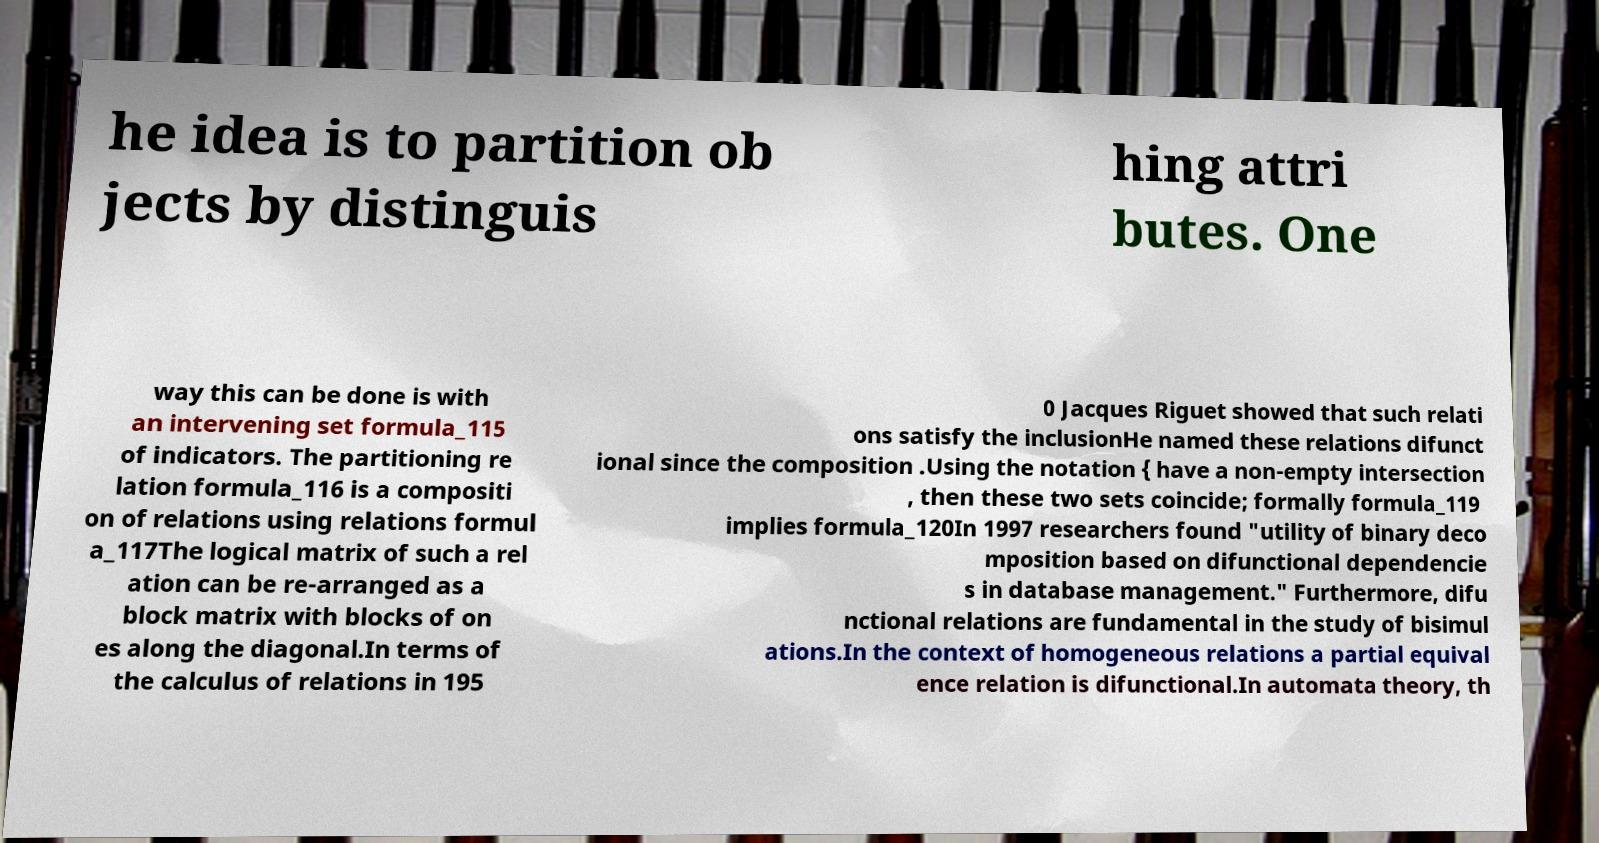For documentation purposes, I need the text within this image transcribed. Could you provide that? he idea is to partition ob jects by distinguis hing attri butes. One way this can be done is with an intervening set formula_115 of indicators. The partitioning re lation formula_116 is a compositi on of relations using relations formul a_117The logical matrix of such a rel ation can be re-arranged as a block matrix with blocks of on es along the diagonal.In terms of the calculus of relations in 195 0 Jacques Riguet showed that such relati ons satisfy the inclusionHe named these relations difunct ional since the composition .Using the notation { have a non-empty intersection , then these two sets coincide; formally formula_119 implies formula_120In 1997 researchers found "utility of binary deco mposition based on difunctional dependencie s in database management." Furthermore, difu nctional relations are fundamental in the study of bisimul ations.In the context of homogeneous relations a partial equival ence relation is difunctional.In automata theory, th 